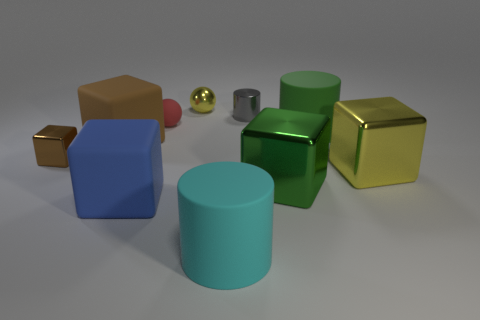Subtract all blue blocks. How many blocks are left? 4 Subtract all large blue cubes. How many cubes are left? 4 Subtract all cyan blocks. Subtract all brown cylinders. How many blocks are left? 5 Subtract all cylinders. How many objects are left? 7 Subtract all big green objects. Subtract all large yellow objects. How many objects are left? 7 Add 7 yellow objects. How many yellow objects are left? 9 Add 5 brown rubber cylinders. How many brown rubber cylinders exist? 5 Subtract 0 cyan spheres. How many objects are left? 10 